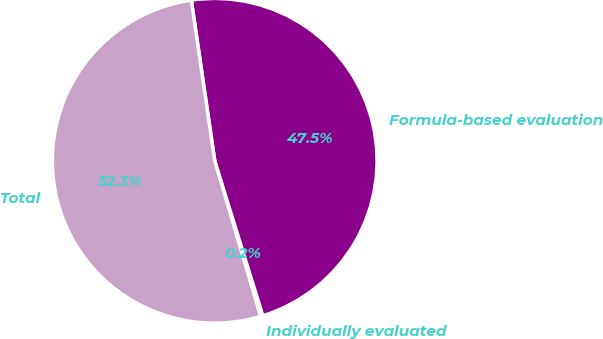Convert chart. <chart><loc_0><loc_0><loc_500><loc_500><pie_chart><fcel>Individually evaluated<fcel>Formula-based evaluation<fcel>Total<nl><fcel>0.23%<fcel>47.51%<fcel>52.26%<nl></chart> 